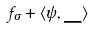Convert formula to latex. <formula><loc_0><loc_0><loc_500><loc_500>f _ { \sigma } + \langle \psi , \_ \rangle</formula> 